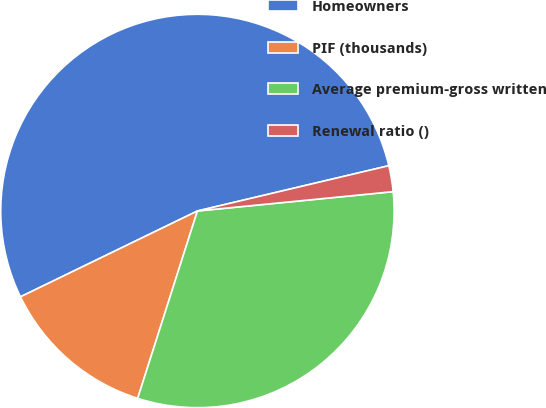Convert chart to OTSL. <chart><loc_0><loc_0><loc_500><loc_500><pie_chart><fcel>Homeowners<fcel>PIF (thousands)<fcel>Average premium-gross written<fcel>Renewal ratio ()<nl><fcel>53.49%<fcel>12.9%<fcel>31.48%<fcel>2.13%<nl></chart> 